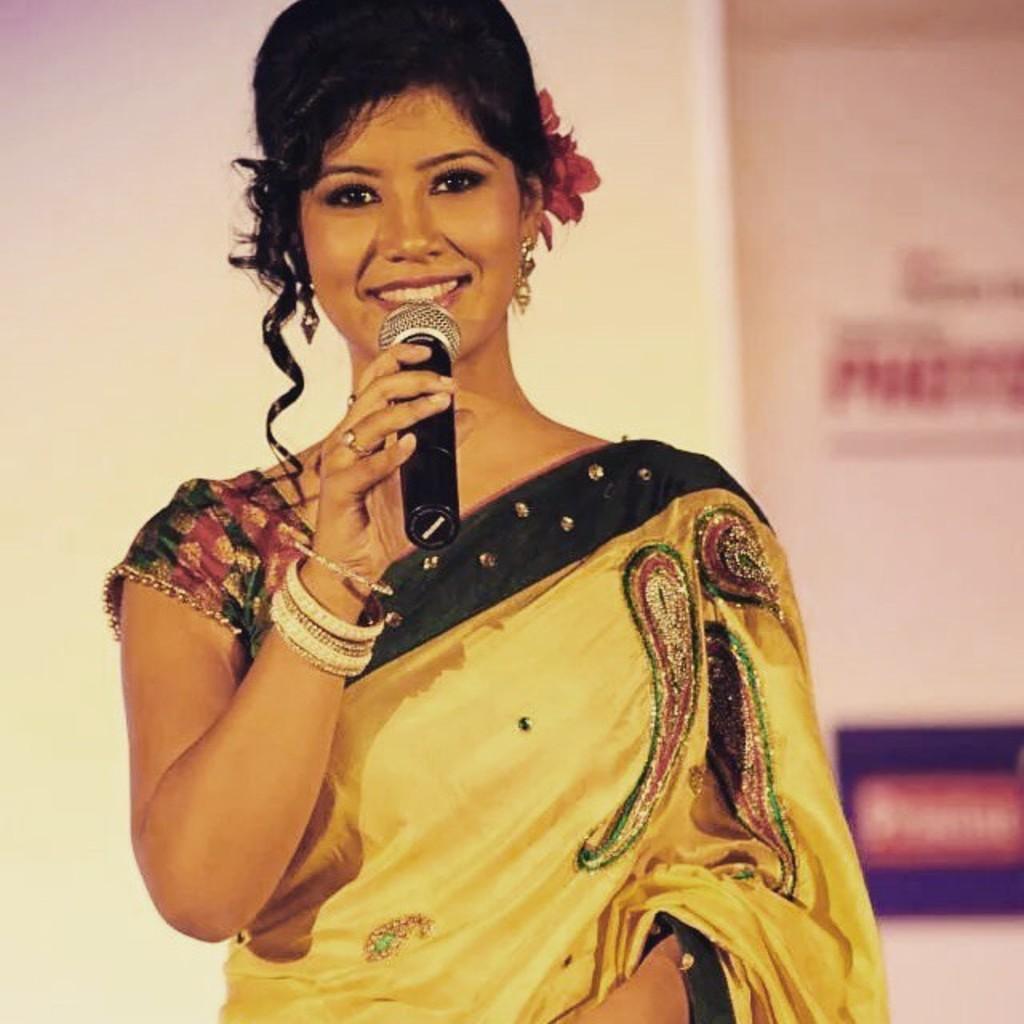Can you describe this image briefly? In the image I can see a lady who is holding the mic. 